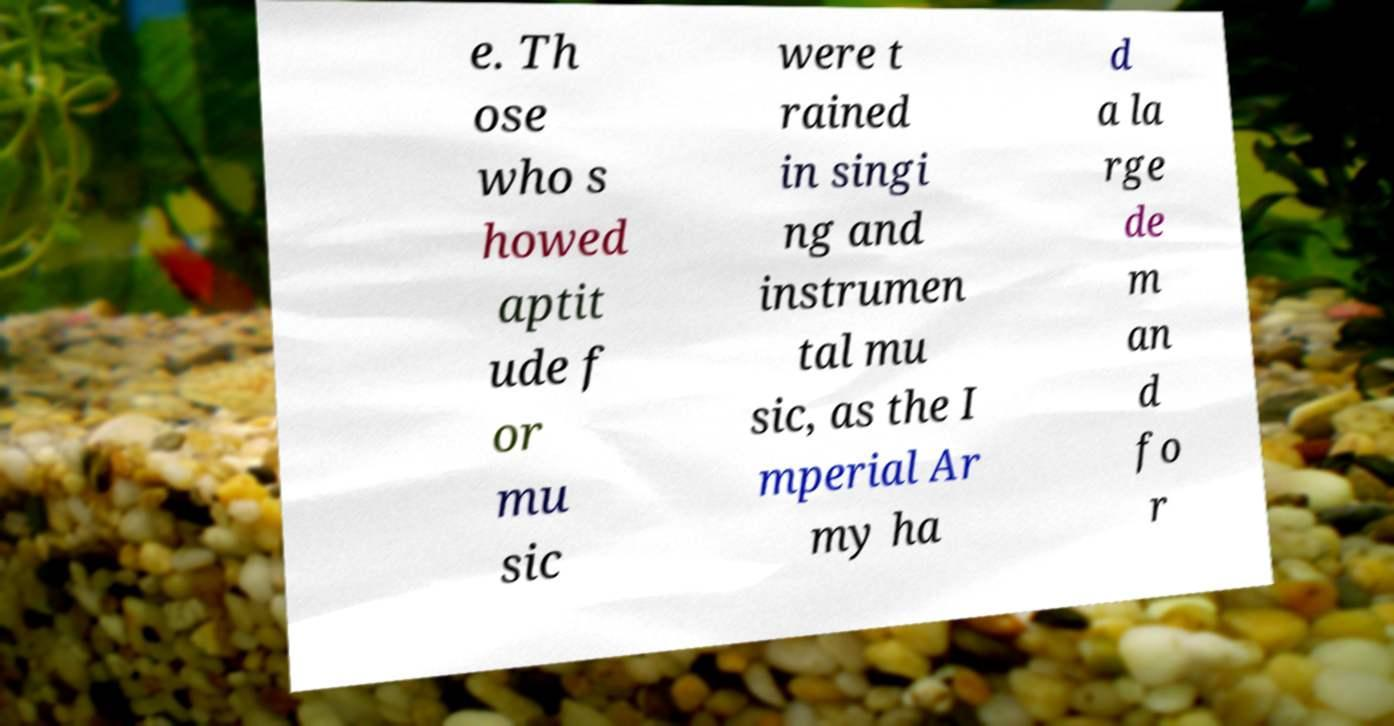Could you assist in decoding the text presented in this image and type it out clearly? e. Th ose who s howed aptit ude f or mu sic were t rained in singi ng and instrumen tal mu sic, as the I mperial Ar my ha d a la rge de m an d fo r 